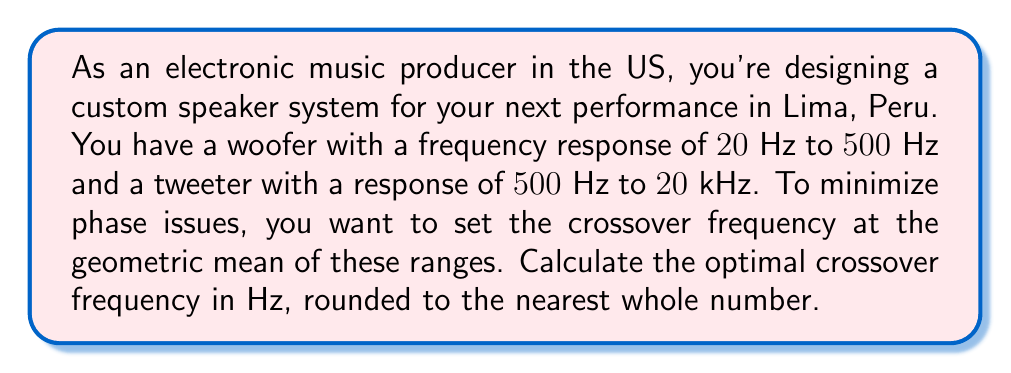Can you solve this math problem? To solve this problem, we'll follow these steps:

1) Identify the frequency ranges:
   Woofer: $20\text{ Hz}$ to $500\text{ Hz}$
   Tweeter: $500\text{ Hz}$ to $20\text{ kHz}$ (or $20000\text{ Hz}$)

2) The geometric mean is the square root of the product of the two extremes. In this case, we'll use the upper limit of the woofer and the lower limit of the tweeter.

3) Let $f_c$ be the crossover frequency. We can express this mathematically as:

   $$f_c = \sqrt{500 \times 500} = \sqrt{250000}$$

4) Calculate the square root:

   $$f_c = 500\text{ Hz}$$

5) The result is already a whole number, so no rounding is necessary.

This frequency will ensure a smooth transition between the woofer and tweeter, minimizing phase issues in your custom speaker system for your performance in Lima.
Answer: $500\text{ Hz}$ 